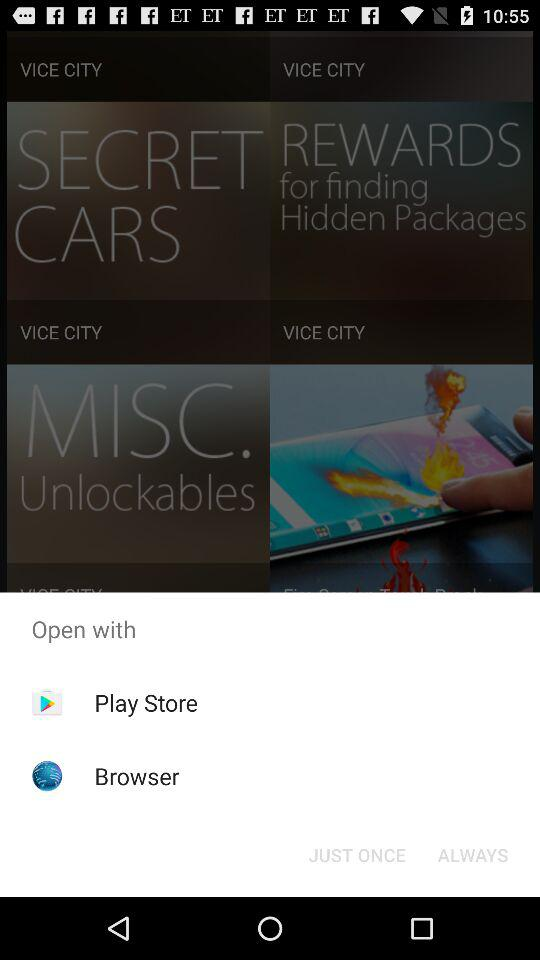What applications can I use to open? You can use "Play Store" and "Browser". 